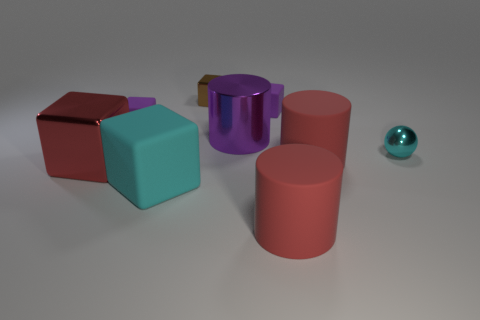There is a rubber thing that is the same color as the metallic sphere; what shape is it?
Your response must be concise. Cube. How many rubber blocks have the same size as the cyan metal thing?
Make the answer very short. 2. How many cyan objects are either tiny matte balls or big shiny blocks?
Provide a short and direct response. 0. There is a purple thing that is behind the small purple object that is to the left of the large cyan matte cube; what is its shape?
Your answer should be very brief. Cube. There is a purple thing that is the same size as the red metallic cube; what shape is it?
Offer a terse response. Cylinder. Is there a cube that has the same color as the large metallic cylinder?
Your answer should be compact. Yes. Are there the same number of big objects in front of the big matte block and large matte cylinders left of the large purple metallic cylinder?
Offer a terse response. No. There is a small brown metallic thing; is its shape the same as the cyan object that is to the left of the cyan metal ball?
Offer a very short reply. Yes. How many other objects are the same material as the purple cylinder?
Ensure brevity in your answer.  3. Are there any red rubber objects in front of the cyan sphere?
Provide a short and direct response. Yes. 